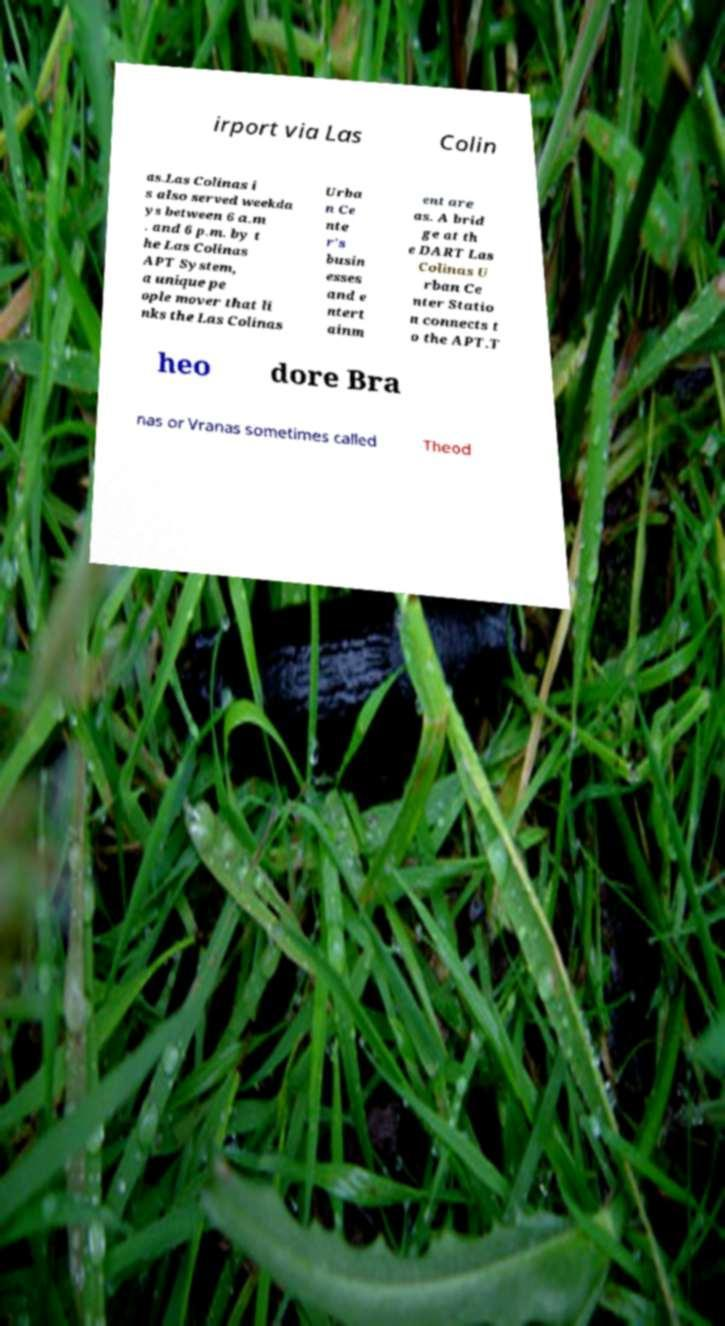For documentation purposes, I need the text within this image transcribed. Could you provide that? irport via Las Colin as.Las Colinas i s also served weekda ys between 6 a.m . and 6 p.m. by t he Las Colinas APT System, a unique pe ople mover that li nks the Las Colinas Urba n Ce nte r's busin esses and e ntert ainm ent are as. A brid ge at th e DART Las Colinas U rban Ce nter Statio n connects t o the APT.T heo dore Bra nas or Vranas sometimes called Theod 